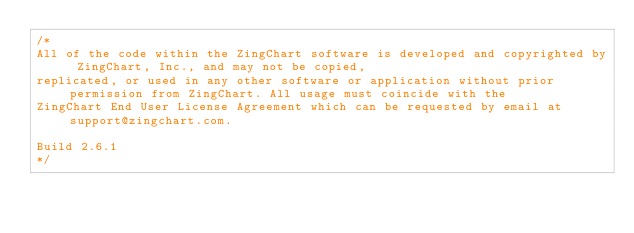Convert code to text. <code><loc_0><loc_0><loc_500><loc_500><_JavaScript_>/*
All of the code within the ZingChart software is developed and copyrighted by ZingChart, Inc., and may not be copied,
replicated, or used in any other software or application without prior permission from ZingChart. All usage must coincide with the
ZingChart End User License Agreement which can be requested by email at support@zingchart.com.

Build 2.6.1
*/</code> 